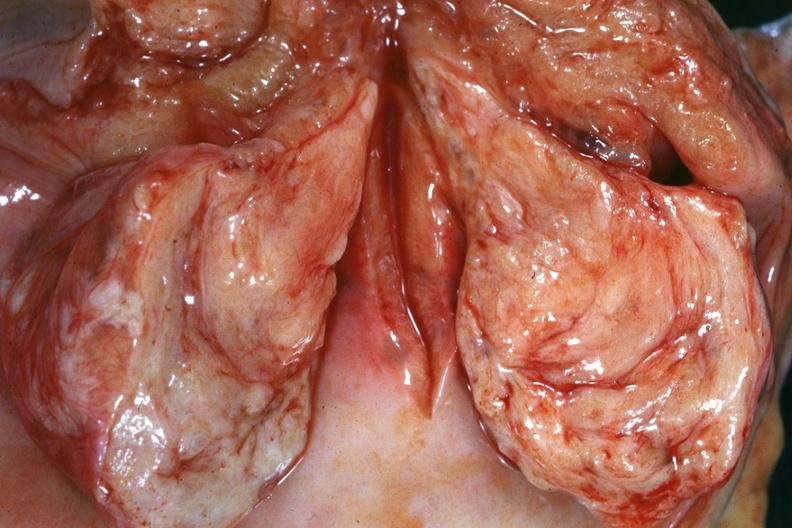what is present?
Answer the question using a single word or phrase. Cervical leiomyoma 